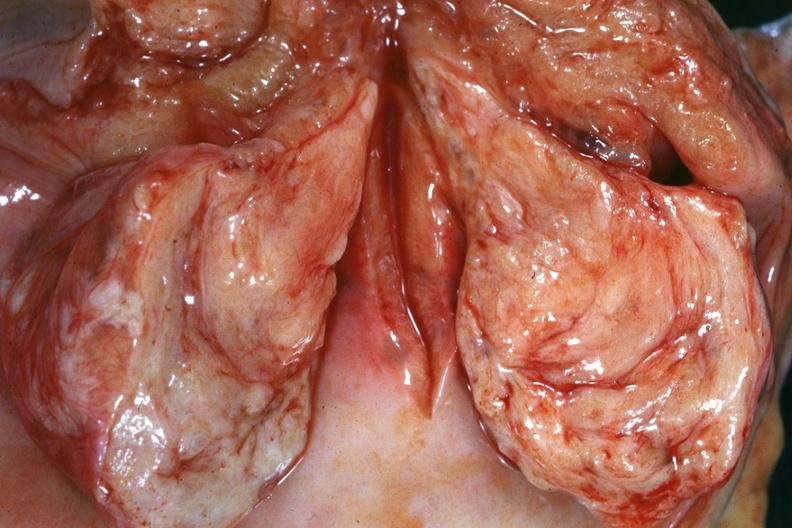what is present?
Answer the question using a single word or phrase. Cervical leiomyoma 